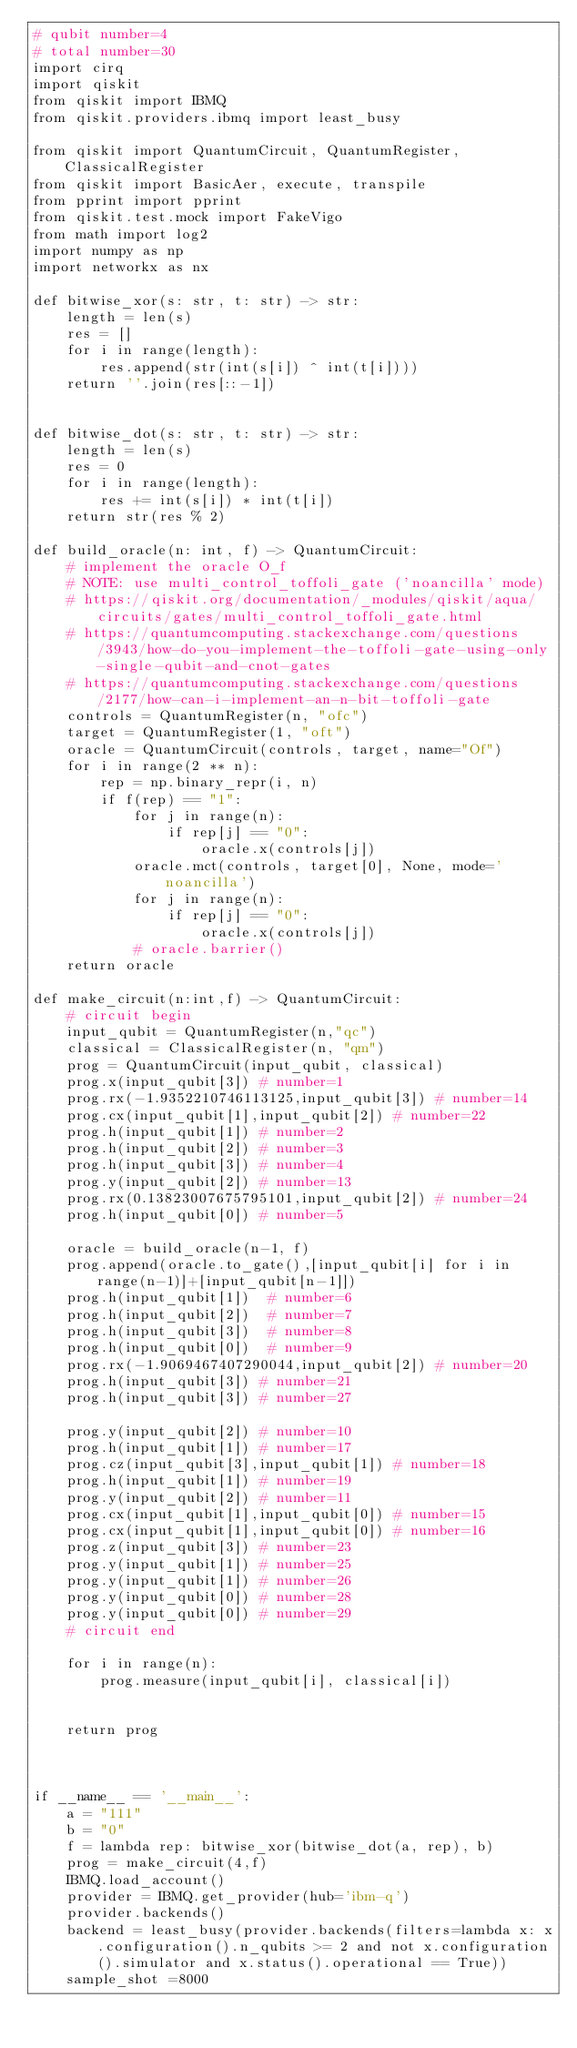Convert code to text. <code><loc_0><loc_0><loc_500><loc_500><_Python_># qubit number=4
# total number=30
import cirq
import qiskit
from qiskit import IBMQ
from qiskit.providers.ibmq import least_busy

from qiskit import QuantumCircuit, QuantumRegister, ClassicalRegister
from qiskit import BasicAer, execute, transpile
from pprint import pprint
from qiskit.test.mock import FakeVigo
from math import log2
import numpy as np
import networkx as nx

def bitwise_xor(s: str, t: str) -> str:
    length = len(s)
    res = []
    for i in range(length):
        res.append(str(int(s[i]) ^ int(t[i])))
    return ''.join(res[::-1])


def bitwise_dot(s: str, t: str) -> str:
    length = len(s)
    res = 0
    for i in range(length):
        res += int(s[i]) * int(t[i])
    return str(res % 2)

def build_oracle(n: int, f) -> QuantumCircuit:
    # implement the oracle O_f
    # NOTE: use multi_control_toffoli_gate ('noancilla' mode)
    # https://qiskit.org/documentation/_modules/qiskit/aqua/circuits/gates/multi_control_toffoli_gate.html
    # https://quantumcomputing.stackexchange.com/questions/3943/how-do-you-implement-the-toffoli-gate-using-only-single-qubit-and-cnot-gates
    # https://quantumcomputing.stackexchange.com/questions/2177/how-can-i-implement-an-n-bit-toffoli-gate
    controls = QuantumRegister(n, "ofc")
    target = QuantumRegister(1, "oft")
    oracle = QuantumCircuit(controls, target, name="Of")
    for i in range(2 ** n):
        rep = np.binary_repr(i, n)
        if f(rep) == "1":
            for j in range(n):
                if rep[j] == "0":
                    oracle.x(controls[j])
            oracle.mct(controls, target[0], None, mode='noancilla')
            for j in range(n):
                if rep[j] == "0":
                    oracle.x(controls[j])
            # oracle.barrier()
    return oracle

def make_circuit(n:int,f) -> QuantumCircuit:
    # circuit begin
    input_qubit = QuantumRegister(n,"qc")
    classical = ClassicalRegister(n, "qm")
    prog = QuantumCircuit(input_qubit, classical)
    prog.x(input_qubit[3]) # number=1
    prog.rx(-1.9352210746113125,input_qubit[3]) # number=14
    prog.cx(input_qubit[1],input_qubit[2]) # number=22
    prog.h(input_qubit[1]) # number=2
    prog.h(input_qubit[2]) # number=3
    prog.h(input_qubit[3]) # number=4
    prog.y(input_qubit[2]) # number=13
    prog.rx(0.13823007675795101,input_qubit[2]) # number=24
    prog.h(input_qubit[0]) # number=5

    oracle = build_oracle(n-1, f)
    prog.append(oracle.to_gate(),[input_qubit[i] for i in range(n-1)]+[input_qubit[n-1]])
    prog.h(input_qubit[1])  # number=6
    prog.h(input_qubit[2])  # number=7
    prog.h(input_qubit[3])  # number=8
    prog.h(input_qubit[0])  # number=9
    prog.rx(-1.9069467407290044,input_qubit[2]) # number=20
    prog.h(input_qubit[3]) # number=21
    prog.h(input_qubit[3]) # number=27

    prog.y(input_qubit[2]) # number=10
    prog.h(input_qubit[1]) # number=17
    prog.cz(input_qubit[3],input_qubit[1]) # number=18
    prog.h(input_qubit[1]) # number=19
    prog.y(input_qubit[2]) # number=11
    prog.cx(input_qubit[1],input_qubit[0]) # number=15
    prog.cx(input_qubit[1],input_qubit[0]) # number=16
    prog.z(input_qubit[3]) # number=23
    prog.y(input_qubit[1]) # number=25
    prog.y(input_qubit[1]) # number=26
    prog.y(input_qubit[0]) # number=28
    prog.y(input_qubit[0]) # number=29
    # circuit end

    for i in range(n):
        prog.measure(input_qubit[i], classical[i])


    return prog



if __name__ == '__main__':
    a = "111"
    b = "0"
    f = lambda rep: bitwise_xor(bitwise_dot(a, rep), b)
    prog = make_circuit(4,f)
    IBMQ.load_account() 
    provider = IBMQ.get_provider(hub='ibm-q') 
    provider.backends()
    backend = least_busy(provider.backends(filters=lambda x: x.configuration().n_qubits >= 2 and not x.configuration().simulator and x.status().operational == True))
    sample_shot =8000
</code> 